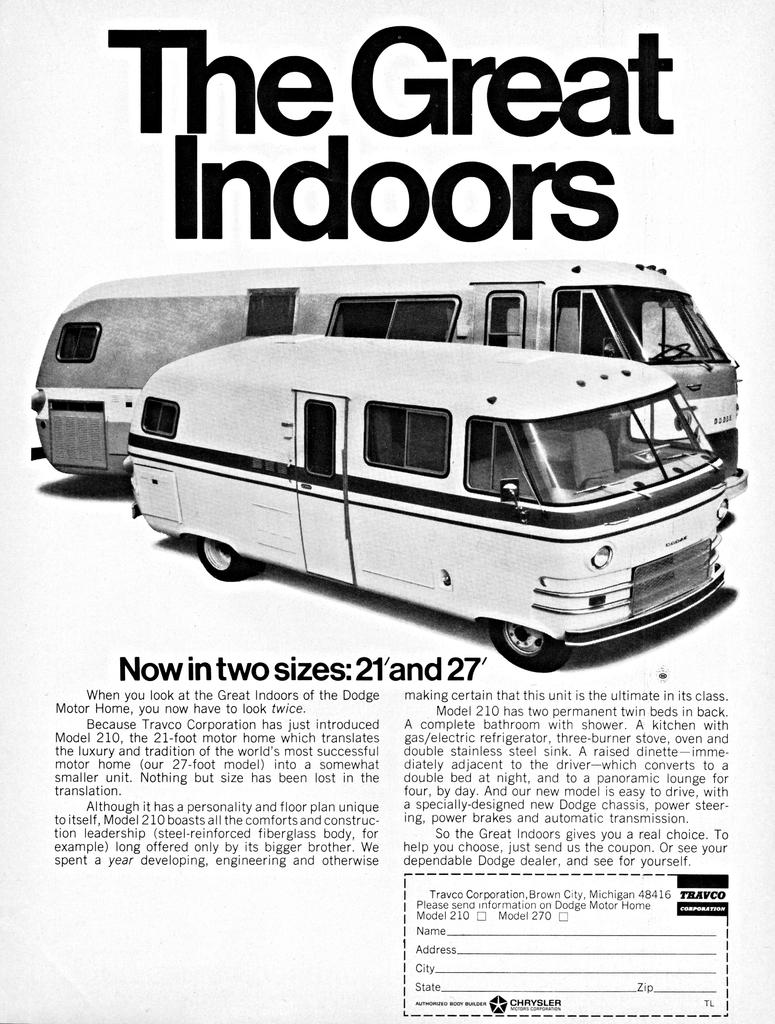<image>
Provide a brief description of the given image. An advertisement for two different sized RV homes. 